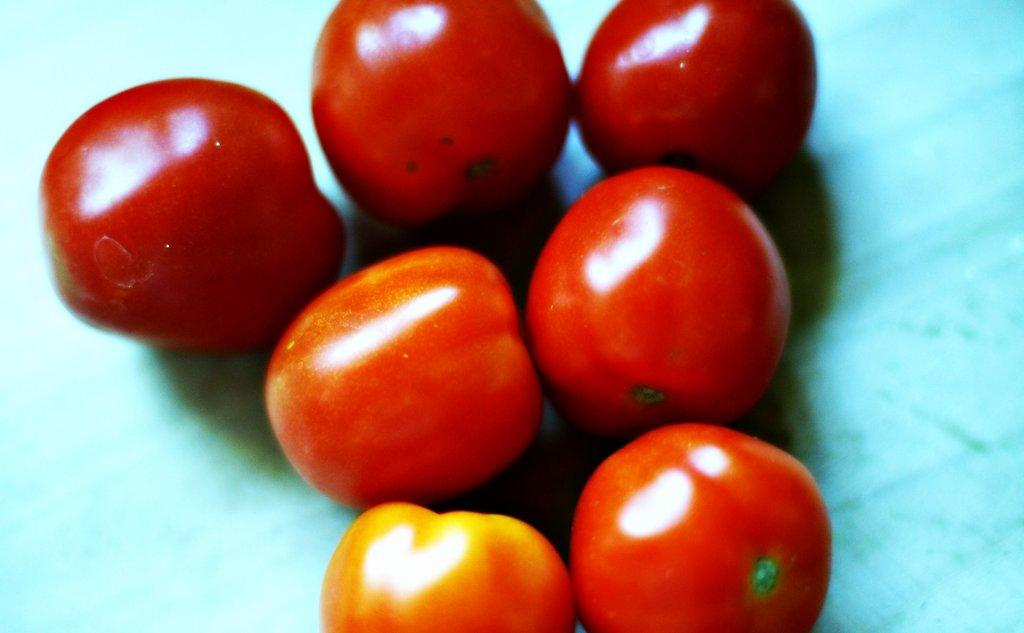How many tomatoes are visible in the image? There are seven tomatoes in the image. How are the tomatoes arranged in the image? The tomatoes are arranged on a surface. What color is the background of the image? The background of the image is blue in color. Can you see a wren perched on top of the tomatoes in the image? No, there is no wren present in the image. 